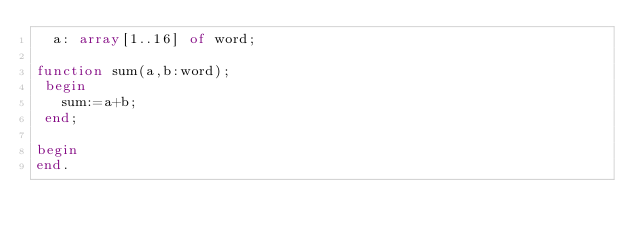<code> <loc_0><loc_0><loc_500><loc_500><_Pascal_>  a: array[1..16] of word;

function sum(a,b:word);
 begin
   sum:=a+b;
 end;

begin
end.

</code> 